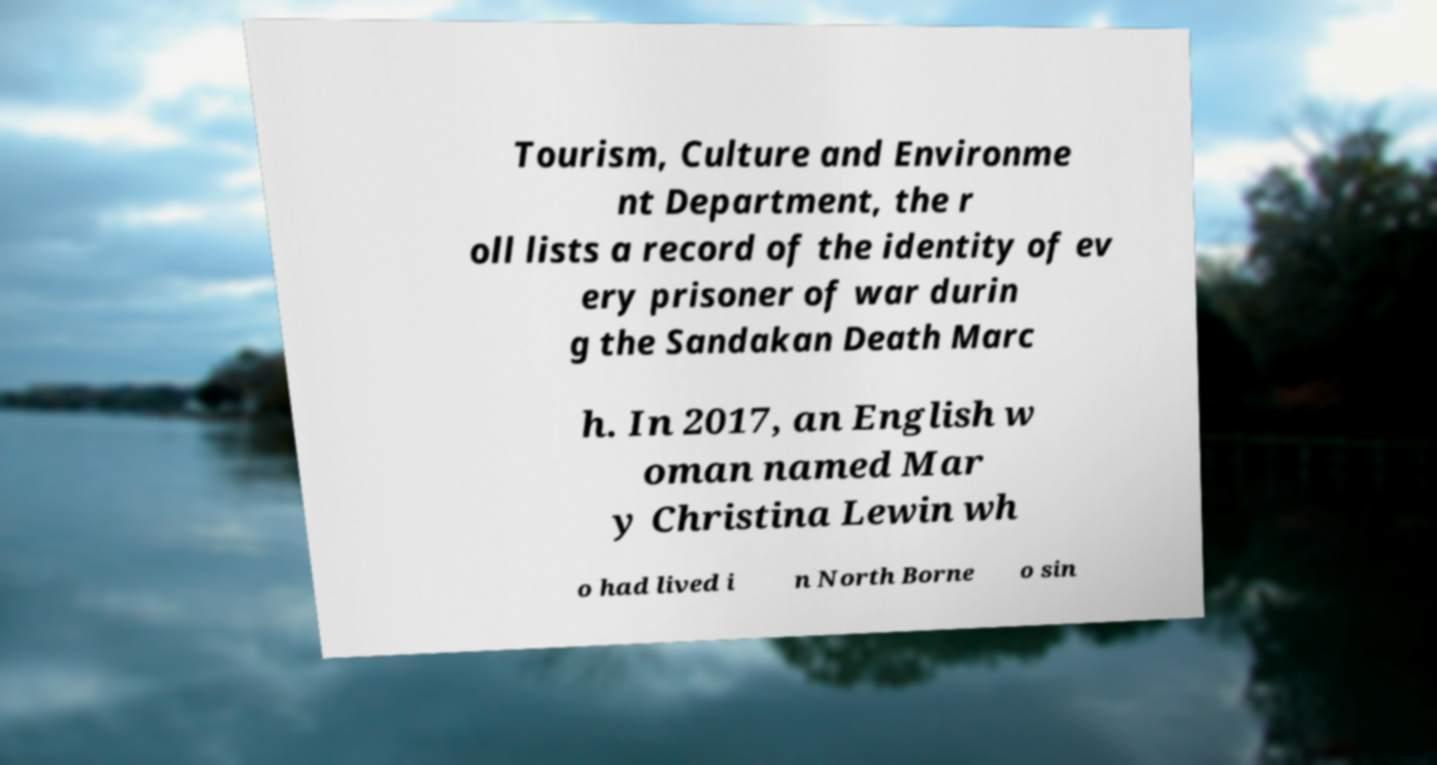What messages or text are displayed in this image? I need them in a readable, typed format. Tourism, Culture and Environme nt Department, the r oll lists a record of the identity of ev ery prisoner of war durin g the Sandakan Death Marc h. In 2017, an English w oman named Mar y Christina Lewin wh o had lived i n North Borne o sin 